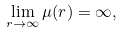Convert formula to latex. <formula><loc_0><loc_0><loc_500><loc_500>\lim _ { r \to \infty } \mu ( r ) = \infty ,</formula> 